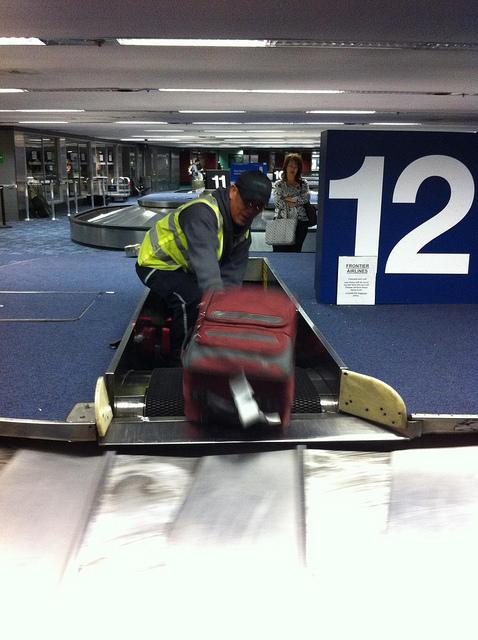Who employs the man in the yellow vest?

Choices:
A) traffic control
B) no one
C) airport
D) city airport 